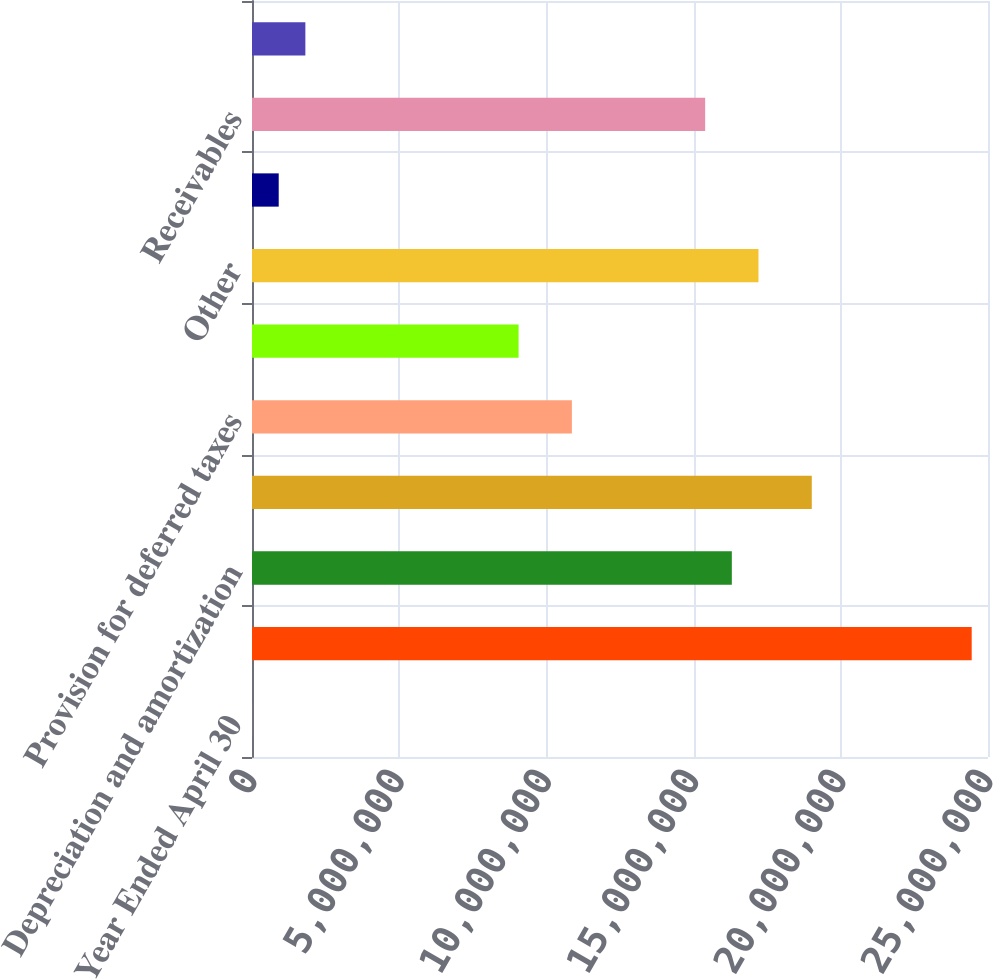Convert chart. <chart><loc_0><loc_0><loc_500><loc_500><bar_chart><fcel>Year Ended April 30<fcel>Net income (loss)<fcel>Depreciation and amortization<fcel>Provision for bad debts and<fcel>Provision for deferred taxes<fcel>Stock-based compensation<fcel>Other<fcel>Cash and cash equivalents -<fcel>Receivables<fcel>Prepaid expenses and other<nl><fcel>2008<fcel>2.44462e+07<fcel>1.62982e+07<fcel>1.90142e+07<fcel>1.08661e+07<fcel>9.05543e+06<fcel>1.72035e+07<fcel>907350<fcel>1.53928e+07<fcel>1.81269e+06<nl></chart> 